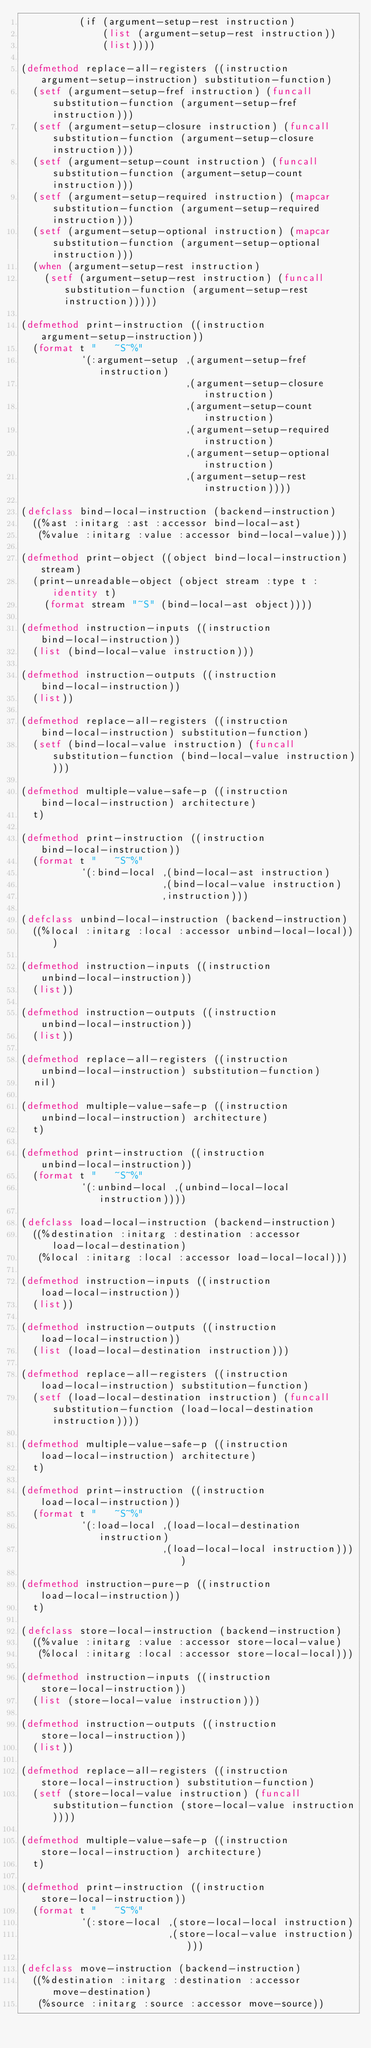<code> <loc_0><loc_0><loc_500><loc_500><_Lisp_>          (if (argument-setup-rest instruction)
              (list (argument-setup-rest instruction))
              (list))))

(defmethod replace-all-registers ((instruction argument-setup-instruction) substitution-function)
  (setf (argument-setup-fref instruction) (funcall substitution-function (argument-setup-fref instruction)))
  (setf (argument-setup-closure instruction) (funcall substitution-function (argument-setup-closure instruction)))
  (setf (argument-setup-count instruction) (funcall substitution-function (argument-setup-count instruction)))
  (setf (argument-setup-required instruction) (mapcar substitution-function (argument-setup-required instruction)))
  (setf (argument-setup-optional instruction) (mapcar substitution-function (argument-setup-optional instruction)))
  (when (argument-setup-rest instruction)
    (setf (argument-setup-rest instruction) (funcall substitution-function (argument-setup-rest instruction)))))

(defmethod print-instruction ((instruction argument-setup-instruction))
  (format t "   ~S~%"
          `(:argument-setup ,(argument-setup-fref instruction)
                            ,(argument-setup-closure instruction)
                            ,(argument-setup-count instruction)
                            ,(argument-setup-required instruction)
                            ,(argument-setup-optional instruction)
                            ,(argument-setup-rest instruction))))

(defclass bind-local-instruction (backend-instruction)
  ((%ast :initarg :ast :accessor bind-local-ast)
   (%value :initarg :value :accessor bind-local-value)))

(defmethod print-object ((object bind-local-instruction) stream)
  (print-unreadable-object (object stream :type t :identity t)
    (format stream "~S" (bind-local-ast object))))

(defmethod instruction-inputs ((instruction bind-local-instruction))
  (list (bind-local-value instruction)))

(defmethod instruction-outputs ((instruction bind-local-instruction))
  (list))

(defmethod replace-all-registers ((instruction bind-local-instruction) substitution-function)
  (setf (bind-local-value instruction) (funcall substitution-function (bind-local-value instruction))))

(defmethod multiple-value-safe-p ((instruction bind-local-instruction) architecture)
  t)

(defmethod print-instruction ((instruction bind-local-instruction))
  (format t "   ~S~%"
          `(:bind-local ,(bind-local-ast instruction)
                        ,(bind-local-value instruction)
                        ,instruction)))

(defclass unbind-local-instruction (backend-instruction)
  ((%local :initarg :local :accessor unbind-local-local)))

(defmethod instruction-inputs ((instruction unbind-local-instruction))
  (list))

(defmethod instruction-outputs ((instruction unbind-local-instruction))
  (list))

(defmethod replace-all-registers ((instruction unbind-local-instruction) substitution-function)
  nil)

(defmethod multiple-value-safe-p ((instruction unbind-local-instruction) architecture)
  t)

(defmethod print-instruction ((instruction unbind-local-instruction))
  (format t "   ~S~%"
          `(:unbind-local ,(unbind-local-local instruction))))

(defclass load-local-instruction (backend-instruction)
  ((%destination :initarg :destination :accessor load-local-destination)
   (%local :initarg :local :accessor load-local-local)))

(defmethod instruction-inputs ((instruction load-local-instruction))
  (list))

(defmethod instruction-outputs ((instruction load-local-instruction))
  (list (load-local-destination instruction)))

(defmethod replace-all-registers ((instruction load-local-instruction) substitution-function)
  (setf (load-local-destination instruction) (funcall substitution-function (load-local-destination instruction))))

(defmethod multiple-value-safe-p ((instruction load-local-instruction) architecture)
  t)

(defmethod print-instruction ((instruction load-local-instruction))
  (format t "   ~S~%"
          `(:load-local ,(load-local-destination instruction)
                        ,(load-local-local instruction))))

(defmethod instruction-pure-p ((instruction load-local-instruction))
  t)

(defclass store-local-instruction (backend-instruction)
  ((%value :initarg :value :accessor store-local-value)
   (%local :initarg :local :accessor store-local-local)))

(defmethod instruction-inputs ((instruction store-local-instruction))
  (list (store-local-value instruction)))

(defmethod instruction-outputs ((instruction store-local-instruction))
  (list))

(defmethod replace-all-registers ((instruction store-local-instruction) substitution-function)
  (setf (store-local-value instruction) (funcall substitution-function (store-local-value instruction))))

(defmethod multiple-value-safe-p ((instruction store-local-instruction) architecture)
  t)

(defmethod print-instruction ((instruction store-local-instruction))
  (format t "   ~S~%"
          `(:store-local ,(store-local-local instruction)
                         ,(store-local-value instruction))))

(defclass move-instruction (backend-instruction)
  ((%destination :initarg :destination :accessor move-destination)
   (%source :initarg :source :accessor move-source))</code> 